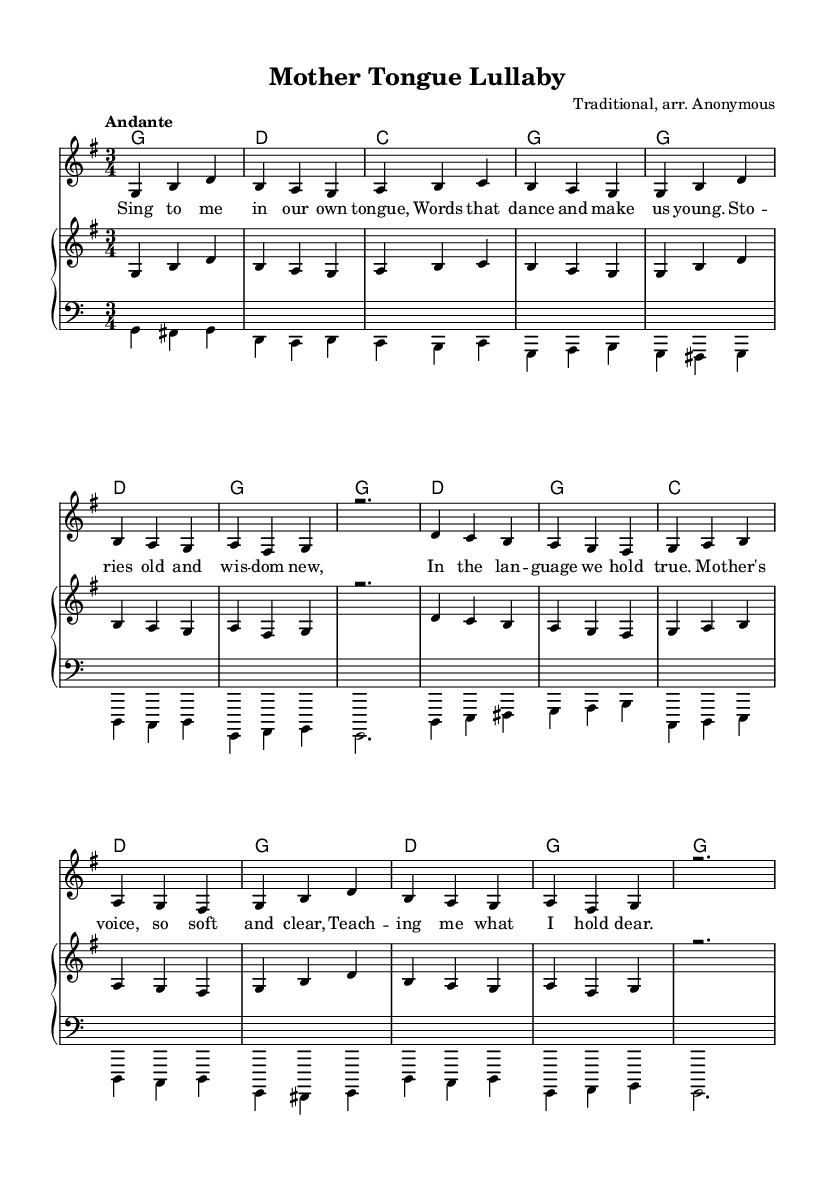What is the title of this music? The title is found in the header section of the sheet music. It states "Mother Tongue Lullaby".
Answer: Mother Tongue Lullaby What is the key signature of this music? The key signature is indicated at the beginning of the staff, showing one sharp, which denotes G major.
Answer: G major What is the time signature of this music? The time signature appears right after the key signature, indicating how many beats are in each measure, which is 3/4.
Answer: 3/4 What is the tempo marking of this music? The tempo is labeled "Andante" in the global section, indicating a moderately slow speed of the piece.
Answer: Andante What is the first lyric line of the song? The lyrics start underneath the melody with the first line being "Sing to me in our own tongue".
Answer: Sing to me in our own tongue How many measures are in the melody? By counting the distinct groups of notes in the melody section, it's revealed that there are 14 measures in total.
Answer: 14 measures What instrument is indicated for the voice part? The instrument for the voice part is specified under the staff as "voice oohs", indicating that it should be performed vocally.
Answer: voice oohs 